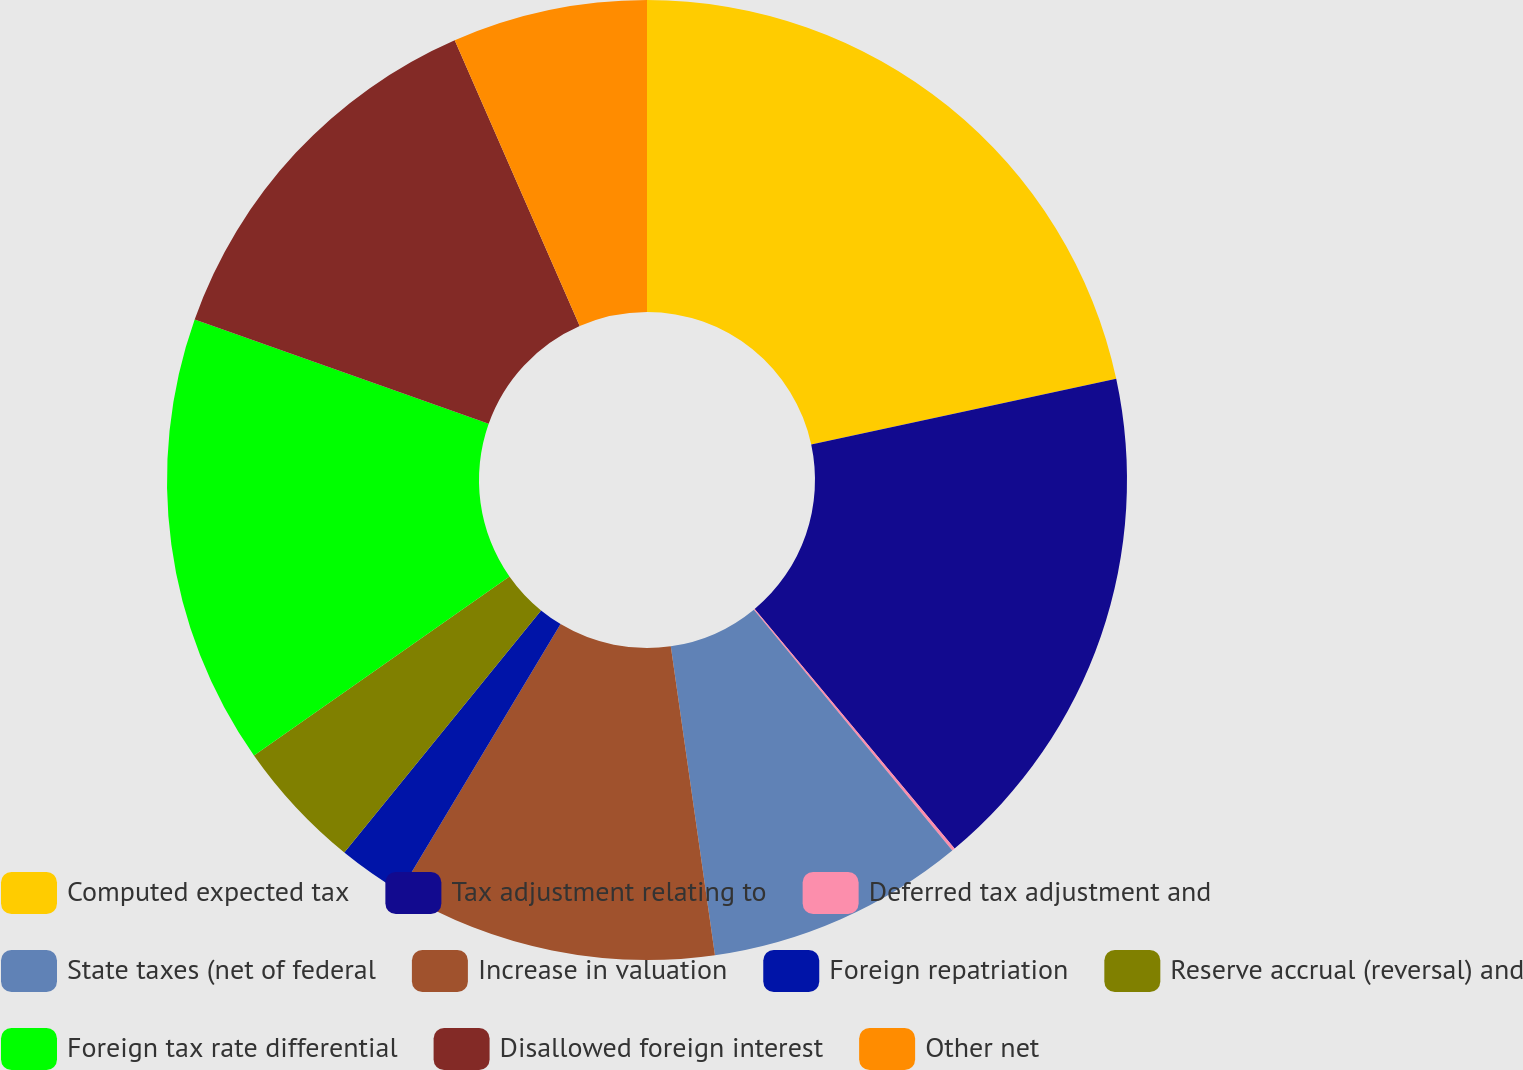<chart> <loc_0><loc_0><loc_500><loc_500><pie_chart><fcel>Computed expected tax<fcel>Tax adjustment relating to<fcel>Deferred tax adjustment and<fcel>State taxes (net of federal<fcel>Increase in valuation<fcel>Foreign repatriation<fcel>Reserve accrual (reversal) and<fcel>Foreign tax rate differential<fcel>Disallowed foreign interest<fcel>Other net<nl><fcel>21.62%<fcel>17.31%<fcel>0.1%<fcel>8.71%<fcel>10.86%<fcel>2.26%<fcel>4.41%<fcel>15.16%<fcel>13.01%<fcel>6.56%<nl></chart> 